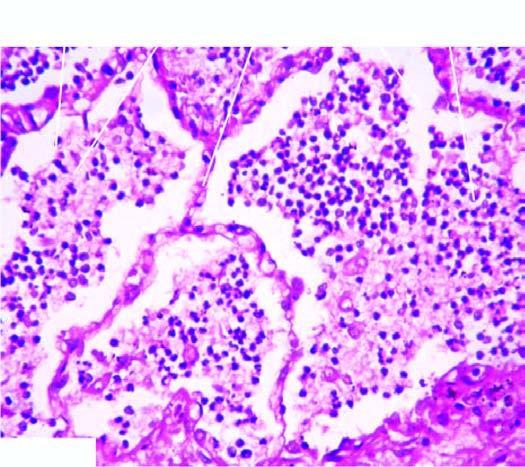s the cellular exudates in the alveolar lumina lying separated from the septal walls by a clear space?
Answer the question using a single word or phrase. Yes 